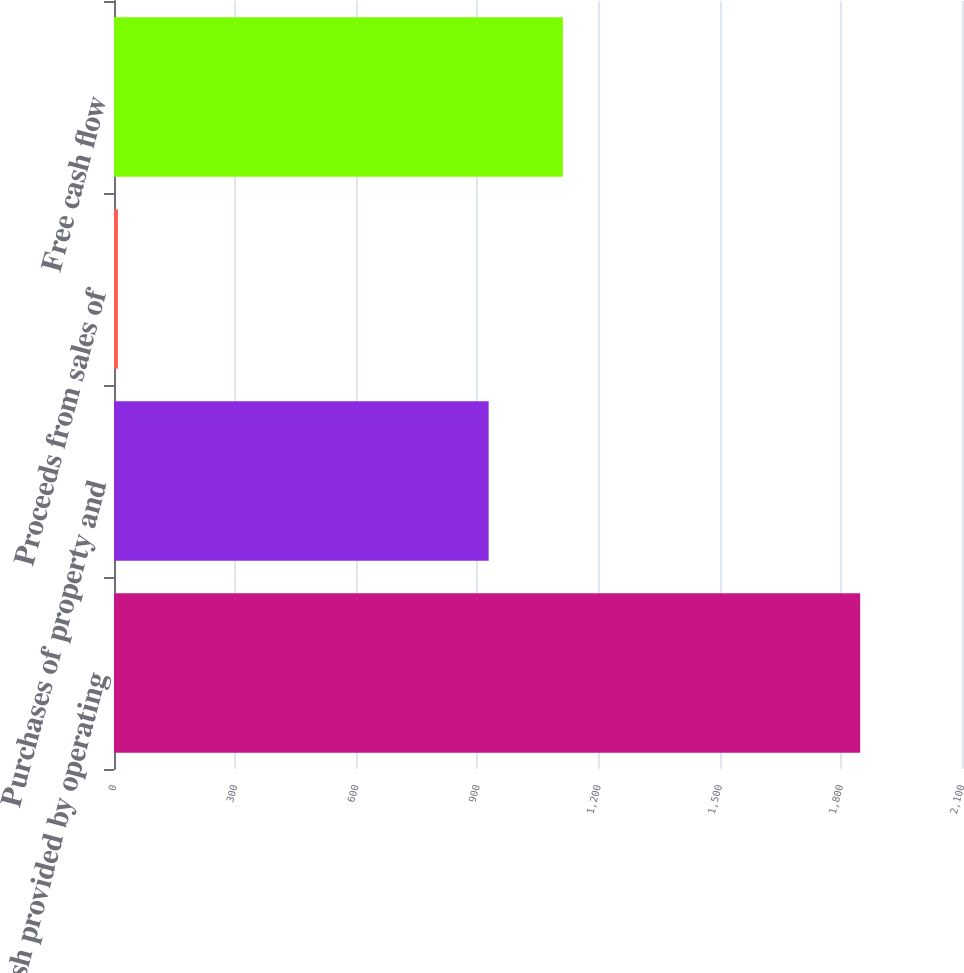Convert chart. <chart><loc_0><loc_0><loc_500><loc_500><bar_chart><fcel>Cash provided by operating<fcel>Purchases of property and<fcel>Proceeds from sales of<fcel>Free cash flow<nl><fcel>1847.8<fcel>927.8<fcel>9.8<fcel>1111.6<nl></chart> 